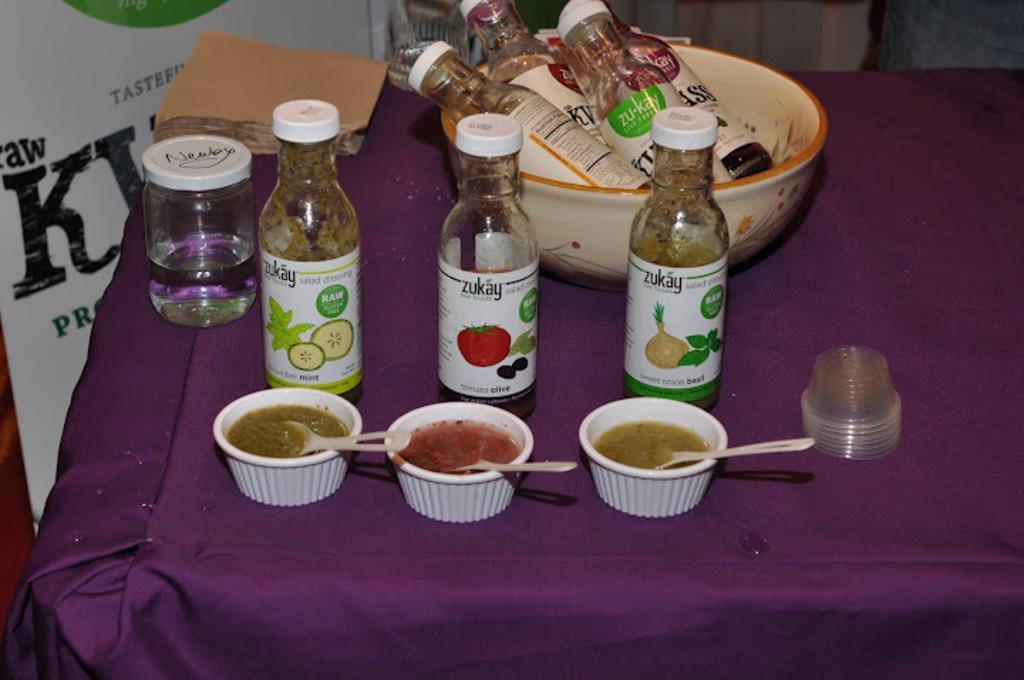Could you give a brief overview of what you see in this image? In this image we can see one table covered with a tablecloth and different objects on the table. There is one banner with some text near the table. 